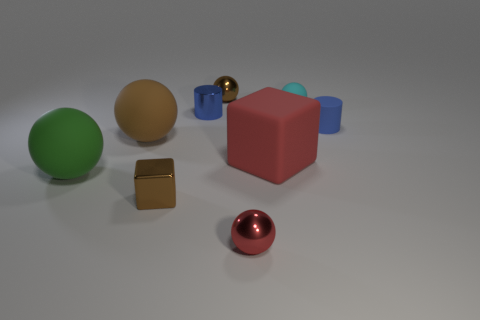Subtract all large matte spheres. How many spheres are left? 3 Add 1 tiny yellow matte balls. How many objects exist? 10 Subtract all spheres. How many objects are left? 4 Subtract all brown cubes. How many cubes are left? 1 Subtract 1 balls. How many balls are left? 4 Subtract all green cubes. Subtract all purple cylinders. How many cubes are left? 2 Subtract all cyan cubes. How many red cylinders are left? 0 Subtract all tiny matte objects. Subtract all matte things. How many objects are left? 2 Add 2 brown matte things. How many brown matte things are left? 3 Add 1 small purple shiny cylinders. How many small purple shiny cylinders exist? 1 